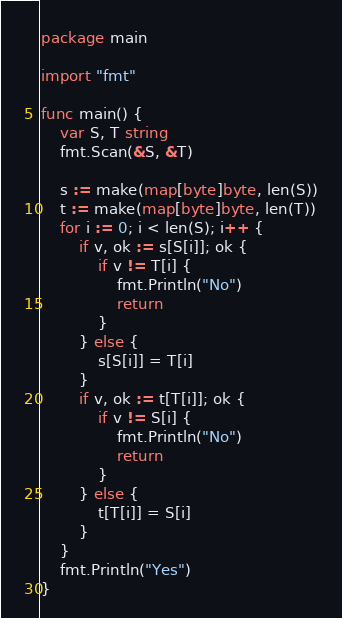Convert code to text. <code><loc_0><loc_0><loc_500><loc_500><_Go_>package main

import "fmt"

func main() {
	var S, T string
	fmt.Scan(&S, &T)

	s := make(map[byte]byte, len(S))
	t := make(map[byte]byte, len(T))
	for i := 0; i < len(S); i++ {
		if v, ok := s[S[i]]; ok {
			if v != T[i] {
				fmt.Println("No")
				return
			}
		} else {
			s[S[i]] = T[i]
		}
		if v, ok := t[T[i]]; ok {
			if v != S[i] {
				fmt.Println("No")
				return
			}
		} else {
			t[T[i]] = S[i]
		}
	}
	fmt.Println("Yes")
}
</code> 